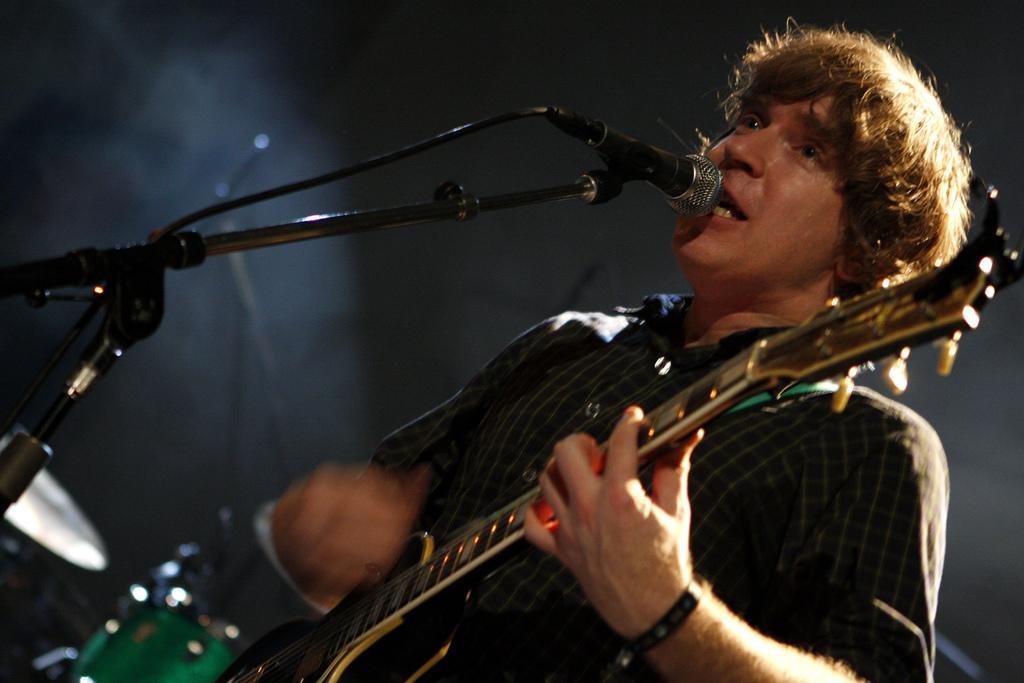Please provide a concise description of this image. A man is singing with a mic in front of him while playing the guitar. There is a light flashing on him from the top. There are some drums in the background. 